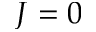Convert formula to latex. <formula><loc_0><loc_0><loc_500><loc_500>J = 0</formula> 